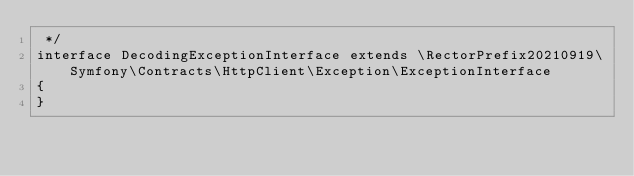Convert code to text. <code><loc_0><loc_0><loc_500><loc_500><_PHP_> */
interface DecodingExceptionInterface extends \RectorPrefix20210919\Symfony\Contracts\HttpClient\Exception\ExceptionInterface
{
}
</code> 